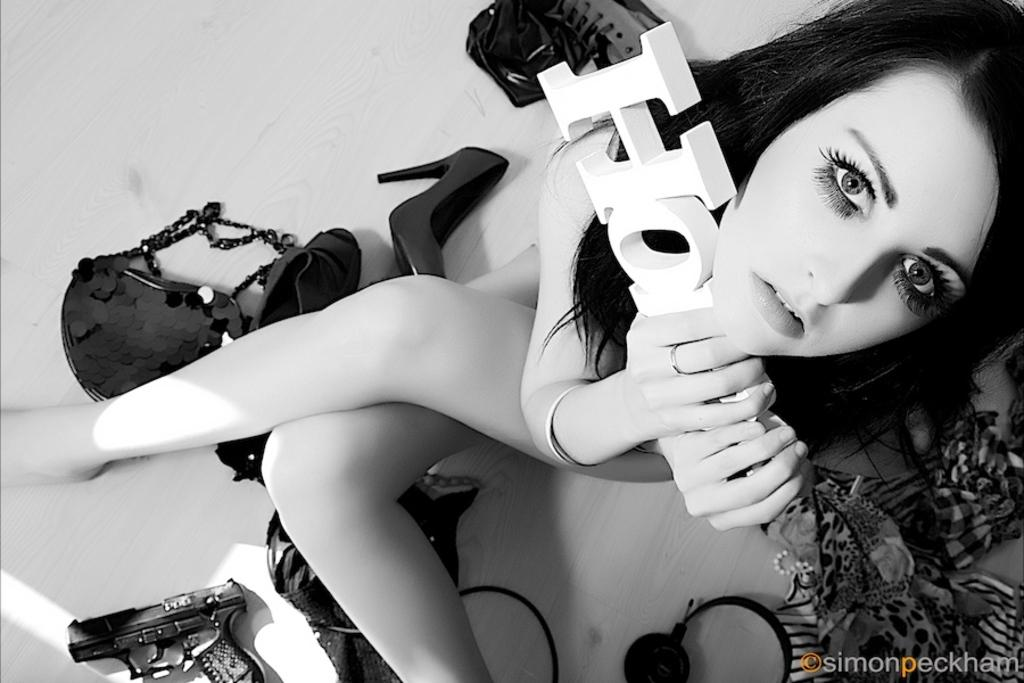What is the main subject of the image? There is a woman in the image. What is the woman holding in her hands? The woman is holding something in her hands, but the facts do not specify what it is. What objects are on the floor in the image? There is a bag, shoes, a gun, and headphones on the floor in the image. What type of wine is the woman drinking in the image? There is no wine present in the image. How many hands does the woman have in the image? The facts do not specify the number of hands the woman has, but since she is a human, she typically has two hands. 